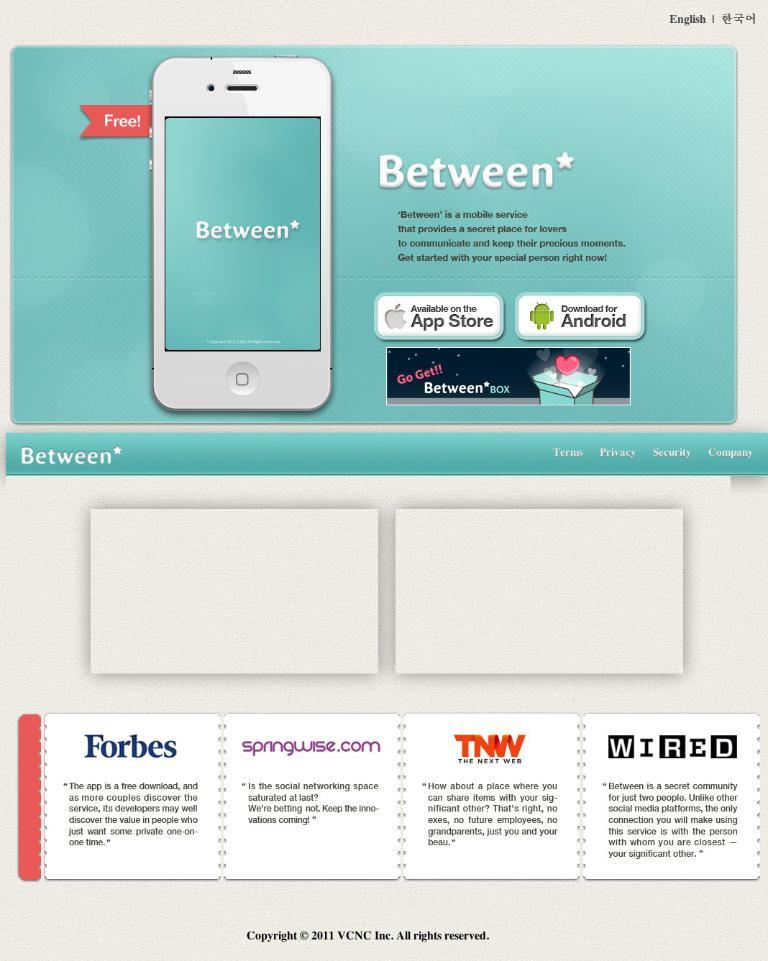What magazine is listed first at the bottom?
Provide a succinct answer. Forbes. What is the word in blue?
Your response must be concise. Forbes. 